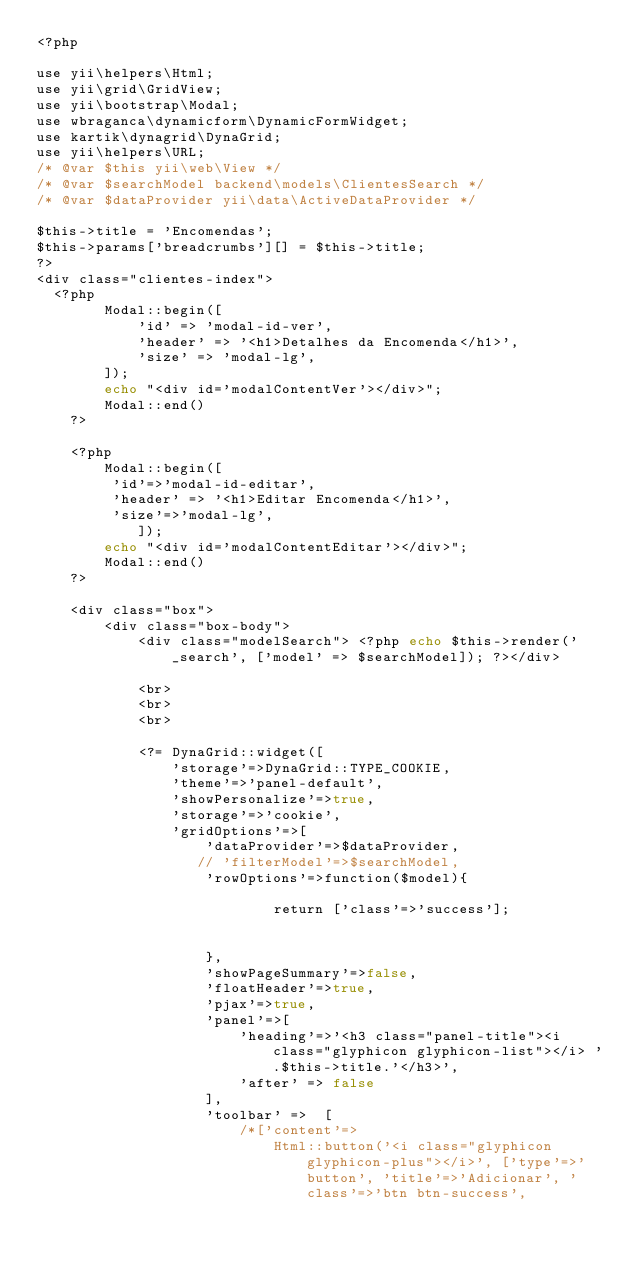<code> <loc_0><loc_0><loc_500><loc_500><_PHP_><?php

use yii\helpers\Html;
use yii\grid\GridView;
use yii\bootstrap\Modal;
use wbraganca\dynamicform\DynamicFormWidget;
use kartik\dynagrid\DynaGrid;
use yii\helpers\URL;
/* @var $this yii\web\View */
/* @var $searchModel backend\models\ClientesSearch */
/* @var $dataProvider yii\data\ActiveDataProvider */

$this->title = 'Encomendas';
$this->params['breadcrumbs'][] = $this->title;
?>
<div class="clientes-index">
  <?php
        Modal::begin([
            'id' => 'modal-id-ver',
            'header' => '<h1>Detalhes da Encomenda</h1>',
            'size' => 'modal-lg',
        ]);
        echo "<div id='modalContentVer'></div>";
        Modal::end()
    ?>

    <?php
        Modal::begin([
         'id'=>'modal-id-editar',
         'header' => '<h1>Editar Encomenda</h1>',
         'size'=>'modal-lg',
            ]);
        echo "<div id='modalContentEditar'></div>";
        Modal::end()
    ?>

    <div class="box">
        <div class="box-body">
            <div class="modelSearch"> <?php echo $this->render('_search', ['model' => $searchModel]); ?></div>

            <br>
            <br>
            <br>
   
            <?= DynaGrid::widget([
                'storage'=>DynaGrid::TYPE_COOKIE,
                'theme'=>'panel-default',
                'showPersonalize'=>true,
                'storage'=>'cookie',
                'gridOptions'=>[
                    'dataProvider'=>$dataProvider,
                   // 'filterModel'=>$searchModel,
                    'rowOptions'=>function($model){

                            return ['class'=>'success'];
                         

                    },
                    'showPageSummary'=>false,
                    'floatHeader'=>true,
                    'pjax'=>true,
                    'panel'=>[
                        'heading'=>'<h3 class="panel-title"><i class="glyphicon glyphicon-list"></i> '.$this->title.'</h3>',
                        'after' => false
                    ],        
                    'toolbar' =>  [
                        /*['content'=>
                            Html::button('<i class="glyphicon glyphicon-plus"></i>', ['type'=>'button', 'title'=>'Adicionar', 'class'=>'btn btn-success', </code> 